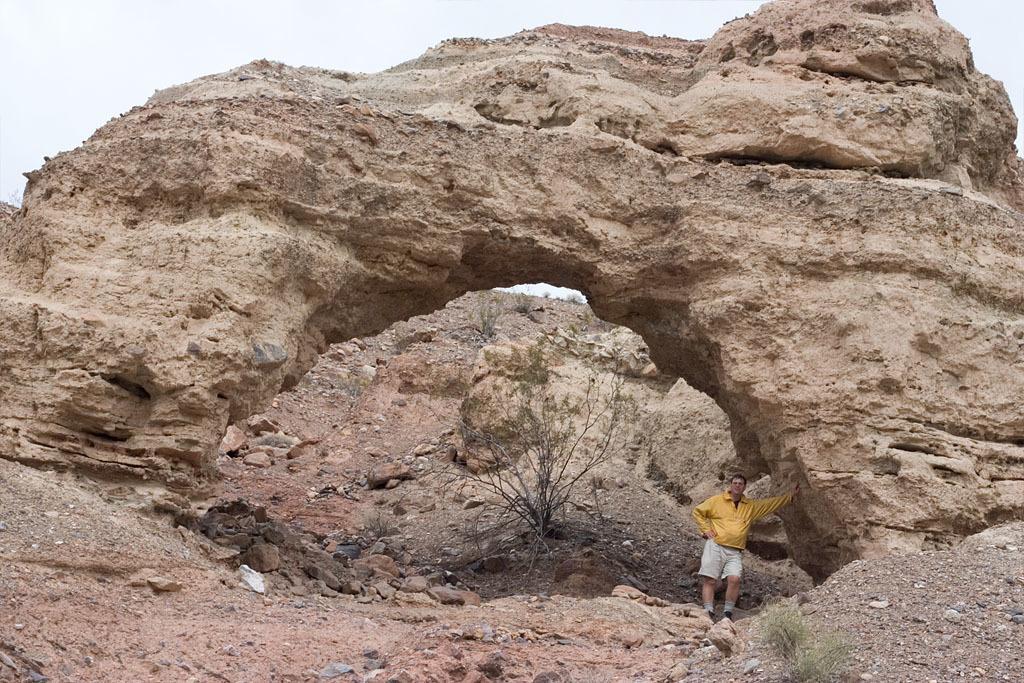Could you give a brief overview of what you see in this image? In this image I can see a person wearing yellow and white colored dress is standing on the rock surface. I can see few plants and a rocky mountain. In the background I can see the sky. 